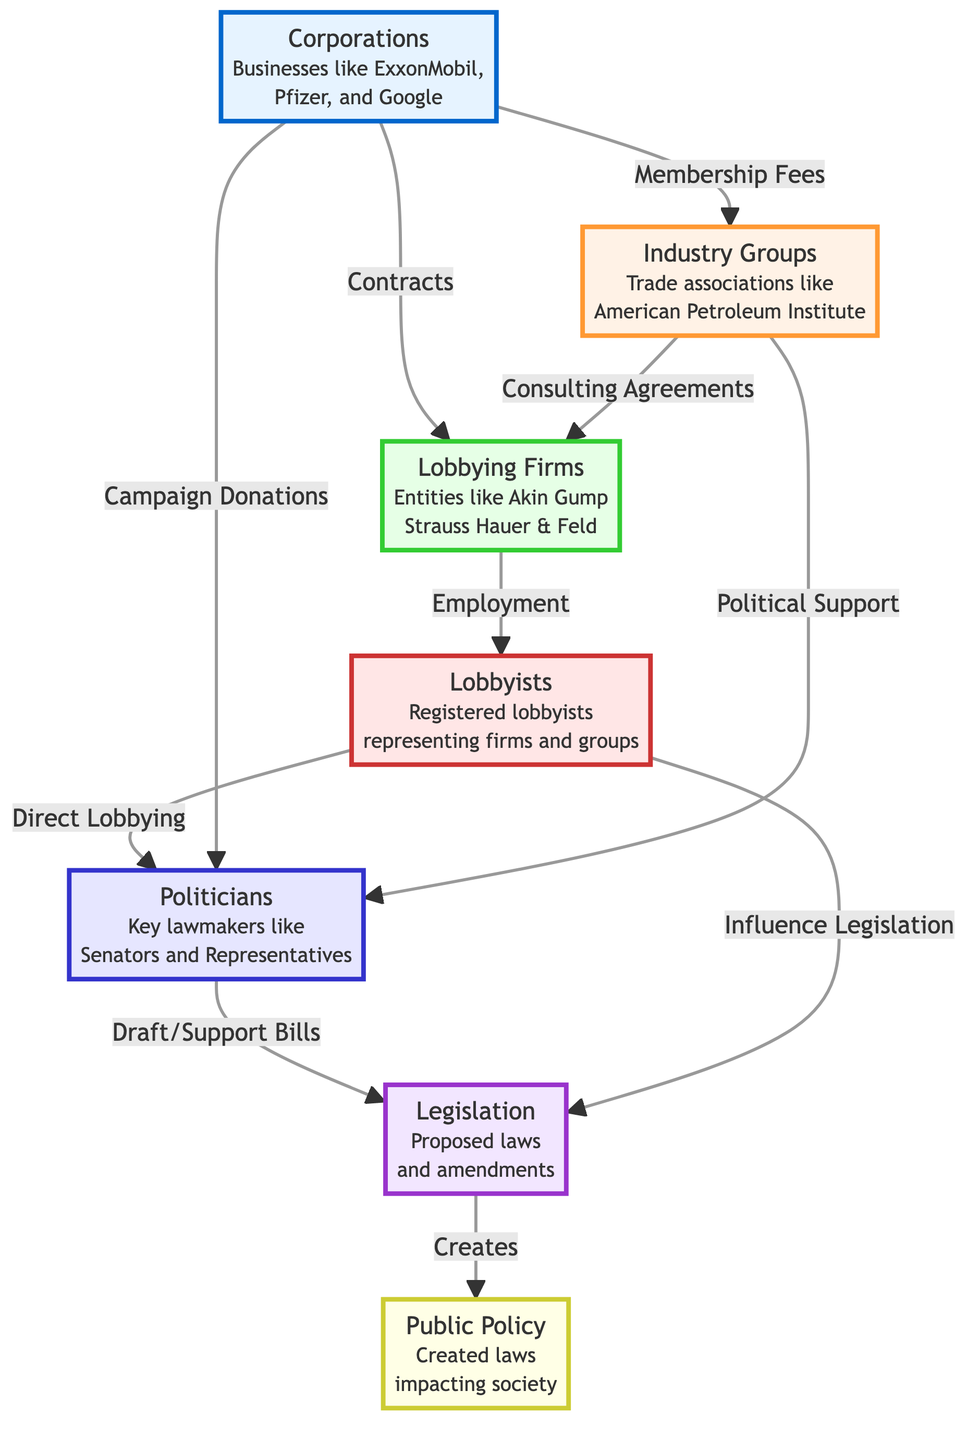What entities provide membership fees? By examining the flowchart, we can see that membership fees are provided by "Corporations," which includes businesses like ExxonMobil, Pfizer, and Google. This connection indicates that those corporations finance industry groups through their membership.
Answer: Corporations How many types of entities are involved in this lobbying process? The flowchart contains seven distinct entities: Corporations, Industry Groups, Lobbying Firms, Lobbyists, Politicians, Legislation, and Public Policy. This can be confirmed by counting the unique labeled elements present in the diagram.
Answer: Seven What do lobbying firms receive from industry groups? The flowchart indicates that lobbying firms receive "Consulting Agreements" from industry groups, which suggests a type of financial or advisory relationship between these two entities.
Answer: Consulting Agreements Which entities influence legislation? According to the flowchart, both Lobbyists and Corporations are shown to influence legislation. Lobbyists do this through their direct lobbying efforts, while corporations can influence legislation via campaign donations.
Answer: Lobbyists, Corporations Who drafts or supports bills? The flowchart illustrates that "Politicians," which include key lawmakers like Senators and Representatives, are responsible for drafting or supporting bills. This is indicated by the direct connection between politicians and the legislation node in the diagram.
Answer: Politicians What is the final outcome created by legislation? The flowchart states that legislation creates "Public Policy," demonstrating the end result of the legislative process as it pertains to influencing laws that impact society.
Answer: Public Policy What is the flow of influence from lobbyists to legislation? From the flowchart, we can trace the influence pathway: Lobbyists engage in direct lobbying activities that connect them to politicians, and politicians then draft or support bills, leading to the formation of legislation. This illustrates a step-by-step connection from lobbyists to the eventual legislative outcome.
Answer: Direct lobbying to politicians to legislation What role do corporations have in supporting politicians? The flowchart specifies that corporations contribute by providing "Campaign Donations" to politicians. This indicates a direct financial influence corporations have over political figures.
Answer: Campaign Donations Which entity receives employment from lobbying firms? The diagram shows that "Lobbyists" are the entities that receive employment from lobbying firms, indicating a flow of human resources and expertise from the firms to the individual lobbyists working on behalf of various interests.
Answer: Lobbyists 